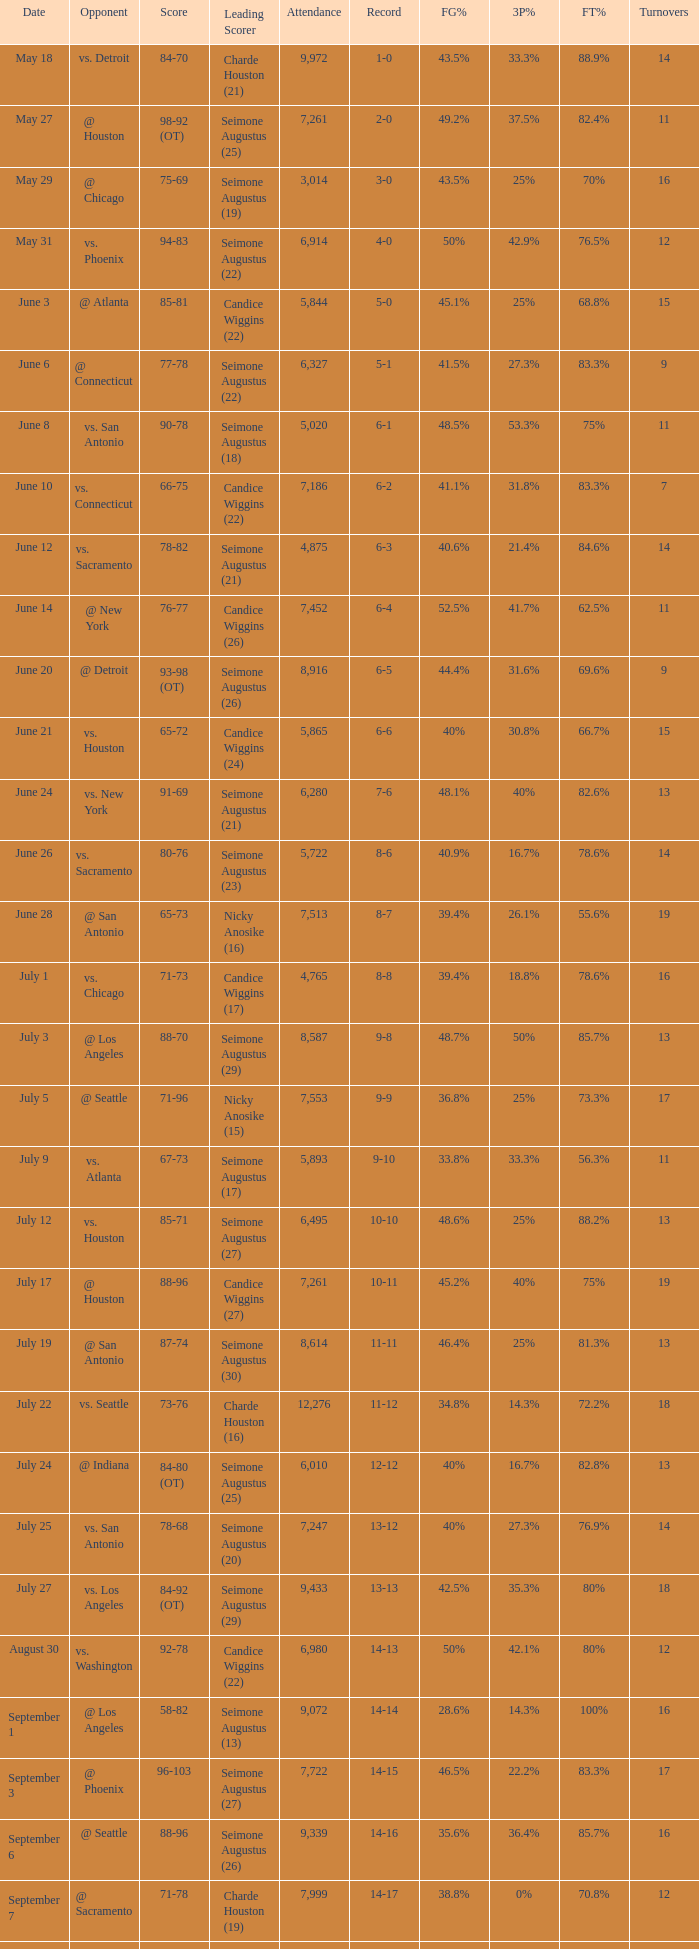Which chief scorer has an opponent from @ seattle and a 14-16 win-loss ratio? Seimone Augustus (26). Can you give me this table as a dict? {'header': ['Date', 'Opponent', 'Score', 'Leading Scorer', 'Attendance', 'Record', 'FG%', '3P%', 'FT%', 'Turnovers'], 'rows': [['May 18', 'vs. Detroit', '84-70', 'Charde Houston (21)', '9,972', '1-0', '43.5%', '33.3%', '88.9%', '14'], ['May 27', '@ Houston', '98-92 (OT)', 'Seimone Augustus (25)', '7,261', '2-0', '49.2%', '37.5%', '82.4%', '11'], ['May 29', '@ Chicago', '75-69', 'Seimone Augustus (19)', '3,014', '3-0', '43.5%', '25%', '70%', '16'], ['May 31', 'vs. Phoenix', '94-83', 'Seimone Augustus (22)', '6,914', '4-0', '50%', '42.9%', '76.5%', '12'], ['June 3', '@ Atlanta', '85-81', 'Candice Wiggins (22)', '5,844', '5-0', '45.1%', '25%', '68.8%', '15'], ['June 6', '@ Connecticut', '77-78', 'Seimone Augustus (22)', '6,327', '5-1', '41.5%', '27.3%', '83.3%', '9'], ['June 8', 'vs. San Antonio', '90-78', 'Seimone Augustus (18)', '5,020', '6-1', '48.5%', '53.3%', '75%', '11'], ['June 10', 'vs. Connecticut', '66-75', 'Candice Wiggins (22)', '7,186', '6-2', '41.1%', '31.8%', '83.3%', '7'], ['June 12', 'vs. Sacramento', '78-82', 'Seimone Augustus (21)', '4,875', '6-3', '40.6%', '21.4%', '84.6%', '14'], ['June 14', '@ New York', '76-77', 'Candice Wiggins (26)', '7,452', '6-4', '52.5%', '41.7%', '62.5%', '11'], ['June 20', '@ Detroit', '93-98 (OT)', 'Seimone Augustus (26)', '8,916', '6-5', '44.4%', '31.6%', '69.6%', '9'], ['June 21', 'vs. Houston', '65-72', 'Candice Wiggins (24)', '5,865', '6-6', '40%', '30.8%', '66.7%', '15'], ['June 24', 'vs. New York', '91-69', 'Seimone Augustus (21)', '6,280', '7-6', '48.1%', '40%', '82.6%', '13'], ['June 26', 'vs. Sacramento', '80-76', 'Seimone Augustus (23)', '5,722', '8-6', '40.9%', '16.7%', '78.6%', '14'], ['June 28', '@ San Antonio', '65-73', 'Nicky Anosike (16)', '7,513', '8-7', '39.4%', '26.1%', '55.6%', '19'], ['July 1', 'vs. Chicago', '71-73', 'Candice Wiggins (17)', '4,765', '8-8', '39.4%', '18.8%', '78.6%', '16'], ['July 3', '@ Los Angeles', '88-70', 'Seimone Augustus (29)', '8,587', '9-8', '48.7%', '50%', '85.7%', '13'], ['July 5', '@ Seattle', '71-96', 'Nicky Anosike (15)', '7,553', '9-9', '36.8%', '25%', '73.3%', '17'], ['July 9', 'vs. Atlanta', '67-73', 'Seimone Augustus (17)', '5,893', '9-10', '33.8%', '33.3%', '56.3%', '11'], ['July 12', 'vs. Houston', '85-71', 'Seimone Augustus (27)', '6,495', '10-10', '48.6%', '25%', '88.2%', '13'], ['July 17', '@ Houston', '88-96', 'Candice Wiggins (27)', '7,261', '10-11', '45.2%', '40%', '75%', '19'], ['July 19', '@ San Antonio', '87-74', 'Seimone Augustus (30)', '8,614', '11-11', '46.4%', '25%', '81.3%', '13'], ['July 22', 'vs. Seattle', '73-76', 'Charde Houston (16)', '12,276', '11-12', '34.8%', '14.3%', '72.2%', '18'], ['July 24', '@ Indiana', '84-80 (OT)', 'Seimone Augustus (25)', '6,010', '12-12', '40%', '16.7%', '82.8%', '13'], ['July 25', 'vs. San Antonio', '78-68', 'Seimone Augustus (20)', '7,247', '13-12', '40%', '27.3%', '76.9%', '14'], ['July 27', 'vs. Los Angeles', '84-92 (OT)', 'Seimone Augustus (29)', '9,433', '13-13', '42.5%', '35.3%', '80%', '18'], ['August 30', 'vs. Washington', '92-78', 'Candice Wiggins (22)', '6,980', '14-13', '50%', '42.1%', '80%', '12'], ['September 1', '@ Los Angeles', '58-82', 'Seimone Augustus (13)', '9,072', '14-14', '28.6%', '14.3%', '100%', '16'], ['September 3', '@ Phoenix', '96-103', 'Seimone Augustus (27)', '7,722', '14-15', '46.5%', '22.2%', '83.3%', '17'], ['September 6', '@ Seattle', '88-96', 'Seimone Augustus (26)', '9,339', '14-16', '35.6%', '36.4%', '85.7%', '16'], ['September 7', '@ Sacramento', '71-78', 'Charde Houston (19)', '7,999', '14-17', '38.8%', '0%', '70.8%', '12'], ['September 9', 'vs. Indiana', '86-76', 'Charde Houston (18)', '6,706', '15-17', '45.6%', '40%', '66.7%', '12'], ['September 12', 'vs. Phoenix', '87-96', 'Lindsey Harding (20)', '8,343', '15-18', '46.4%', '16.7%', '69.2%', '15'], ['September 14', '@ Washington', '96-70', 'Charde Houston (18)', '10,438', '16-18', '55.4%', '46.2%', '88.2%', '10']]} 